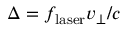<formula> <loc_0><loc_0><loc_500><loc_500>\Delta = f _ { l a s e r } v _ { \perp } / c</formula> 